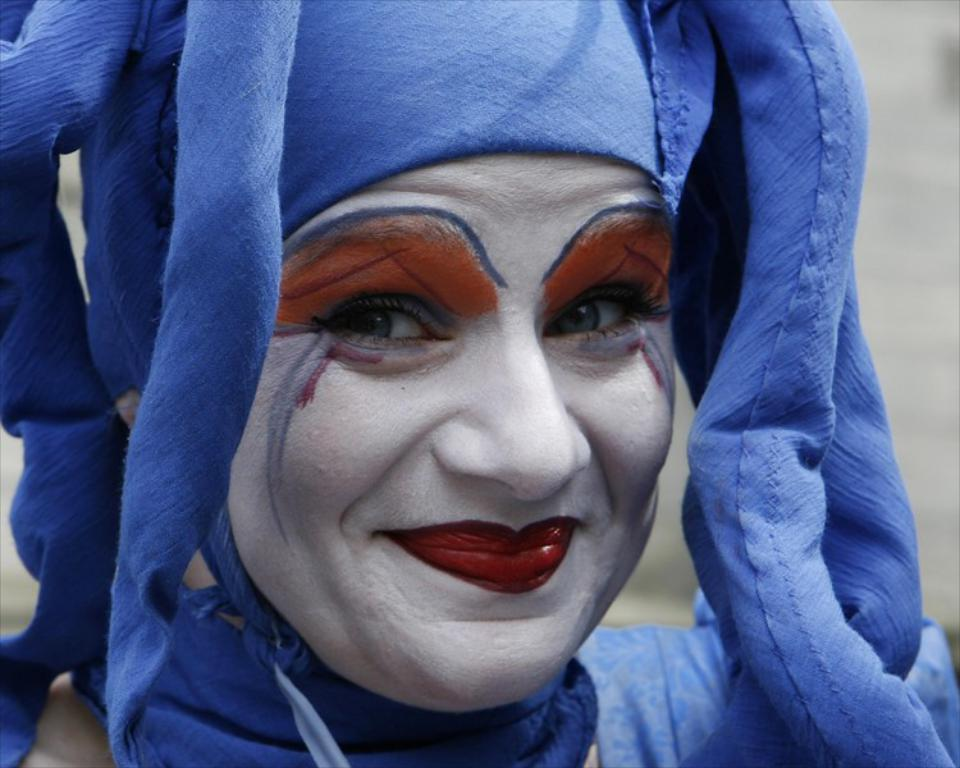Who or what is present in the image? There is a person in the image. What is the person doing in the image? The person is smiling. What is the person wearing in the image? The person is wearing a costume. Can you describe the background of the image? The background of the image is blurry. How many pieces of pie are visible in the image? There are no pieces of pie present in the image. What is the fifth element in the image? The image only contains four elements: a person, a smile, a costume, and a blurry background. There is no fifth element. 